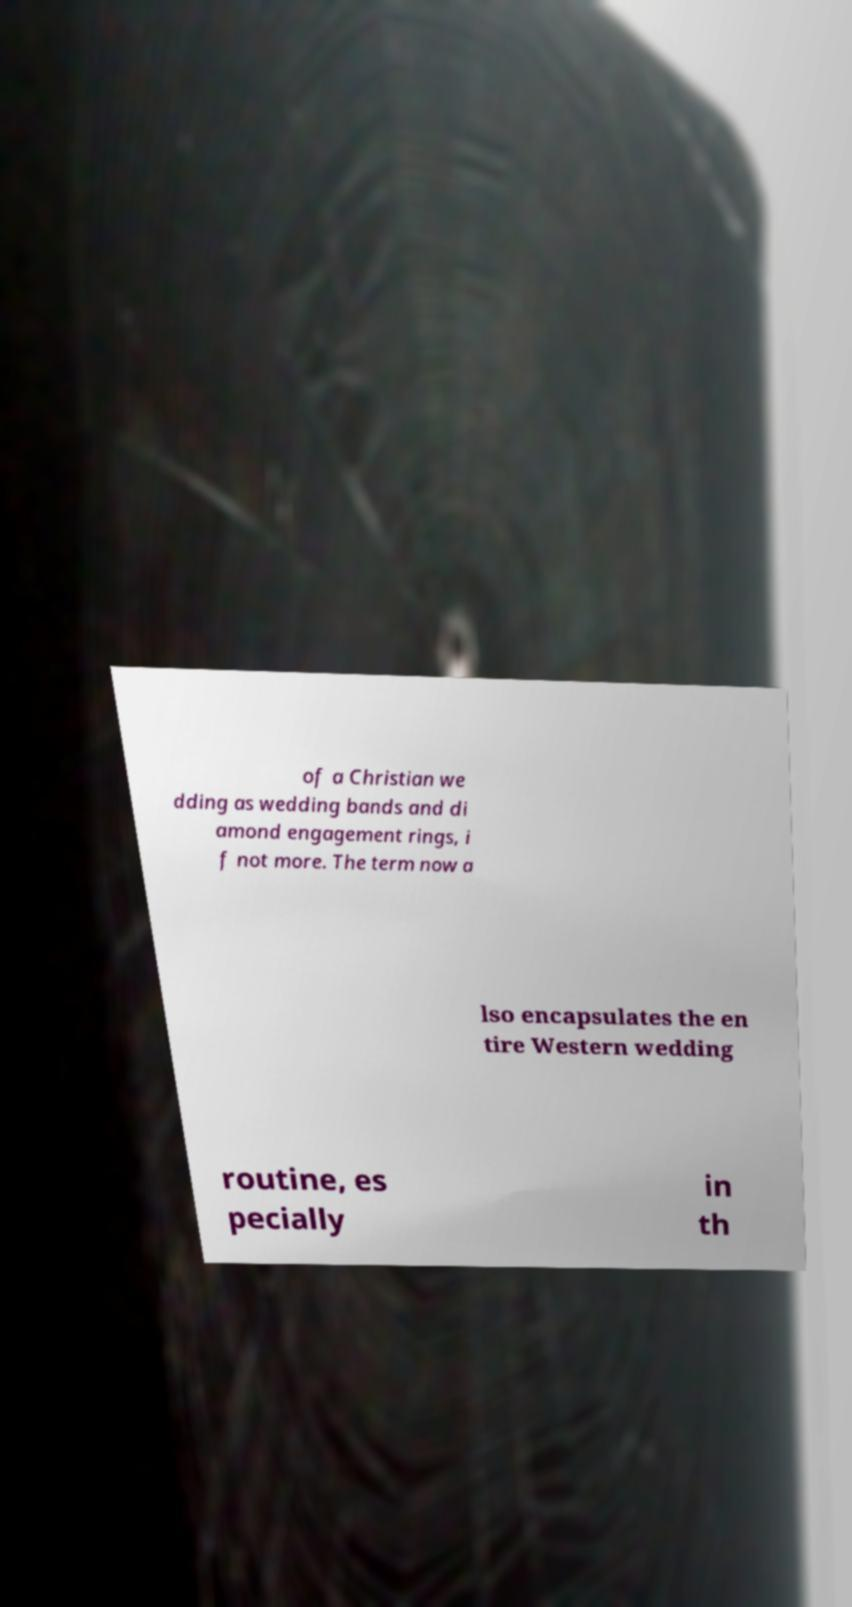What messages or text are displayed in this image? I need them in a readable, typed format. of a Christian we dding as wedding bands and di amond engagement rings, i f not more. The term now a lso encapsulates the en tire Western wedding routine, es pecially in th 